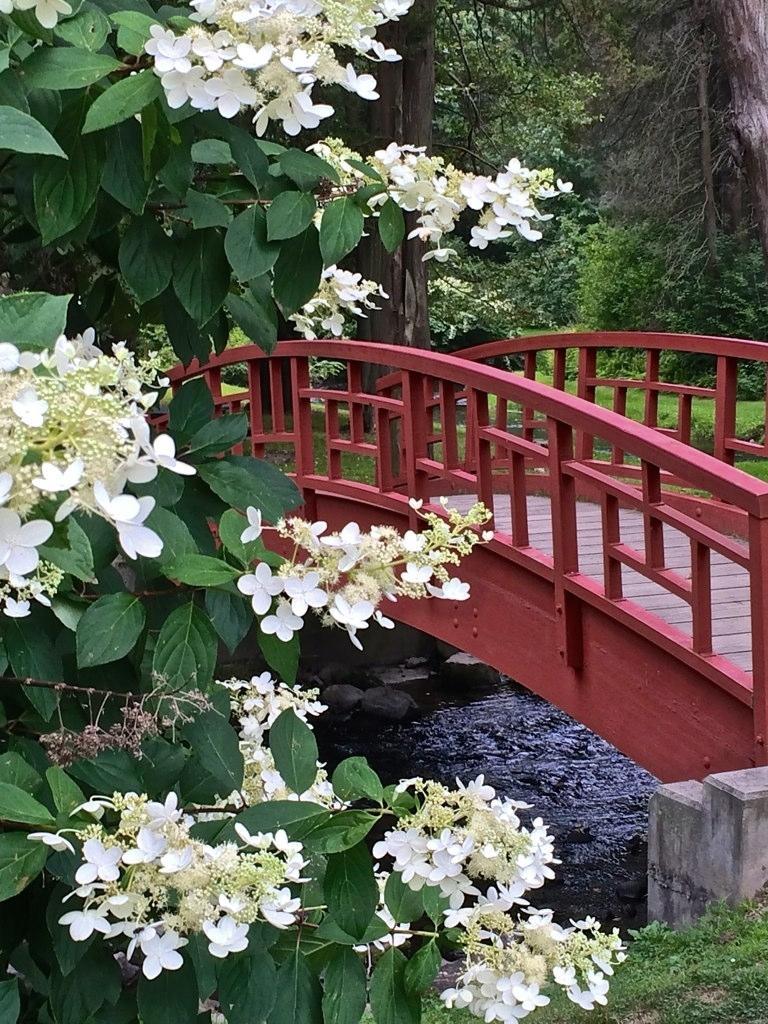Can you describe this image briefly? In this image in the front there are flowers and plants. In the center there is water and there is a bridge. In the background there are trees and there's grass on the ground. 